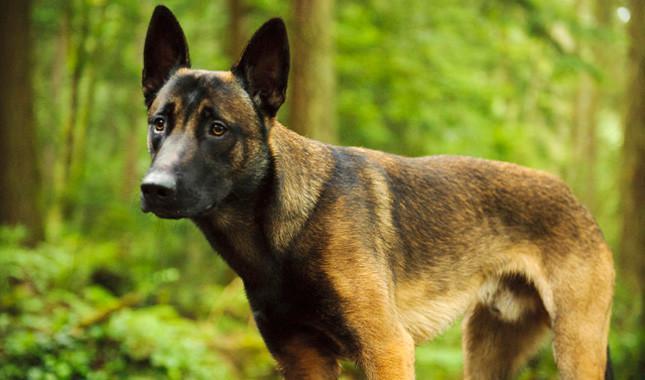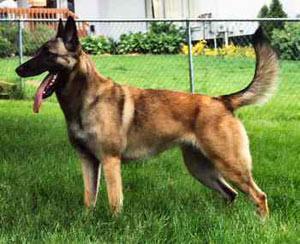The first image is the image on the left, the second image is the image on the right. Evaluate the accuracy of this statement regarding the images: "All dogs have their tongue sticking out.". Is it true? Answer yes or no. No. 